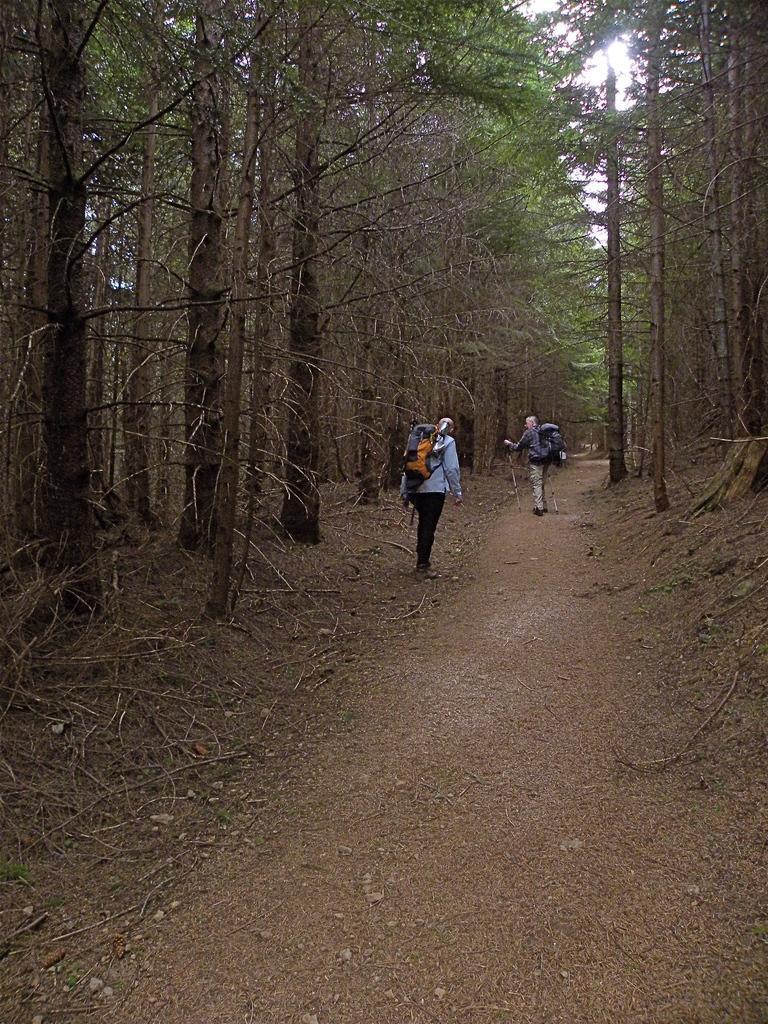In one or two sentences, can you explain what this image depicts? In this picture there are two persons standing. At the back there are trees. At the top there is sky. At the bottom there are tree branches and stones. 